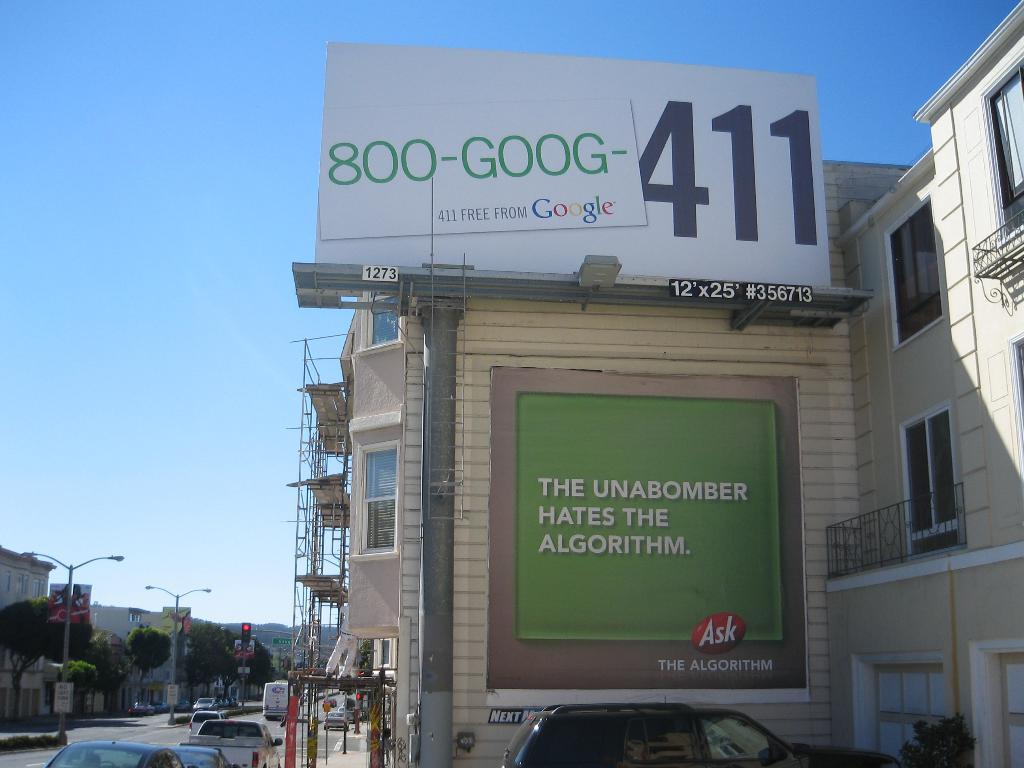<image>
Present a compact description of the photo's key features. A green sign says that the unabomber hates the algorithm. 